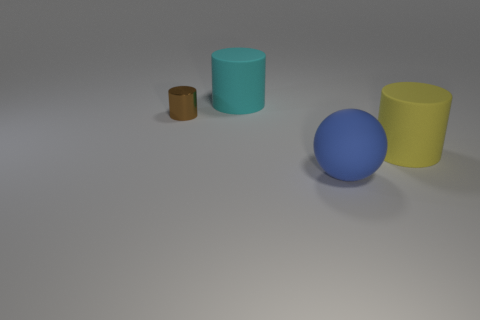Subtract all brown cylinders. How many cylinders are left? 2 Subtract 2 cylinders. How many cylinders are left? 1 Add 1 blue balls. How many objects exist? 5 Subtract all yellow cylinders. How many cylinders are left? 2 Subtract all cylinders. How many objects are left? 1 Subtract all yellow cylinders. Subtract all red blocks. How many cylinders are left? 2 Subtract all blue cylinders. How many gray balls are left? 0 Subtract all large cylinders. Subtract all cyan rubber cylinders. How many objects are left? 1 Add 3 rubber things. How many rubber things are left? 6 Add 3 small purple rubber balls. How many small purple rubber balls exist? 3 